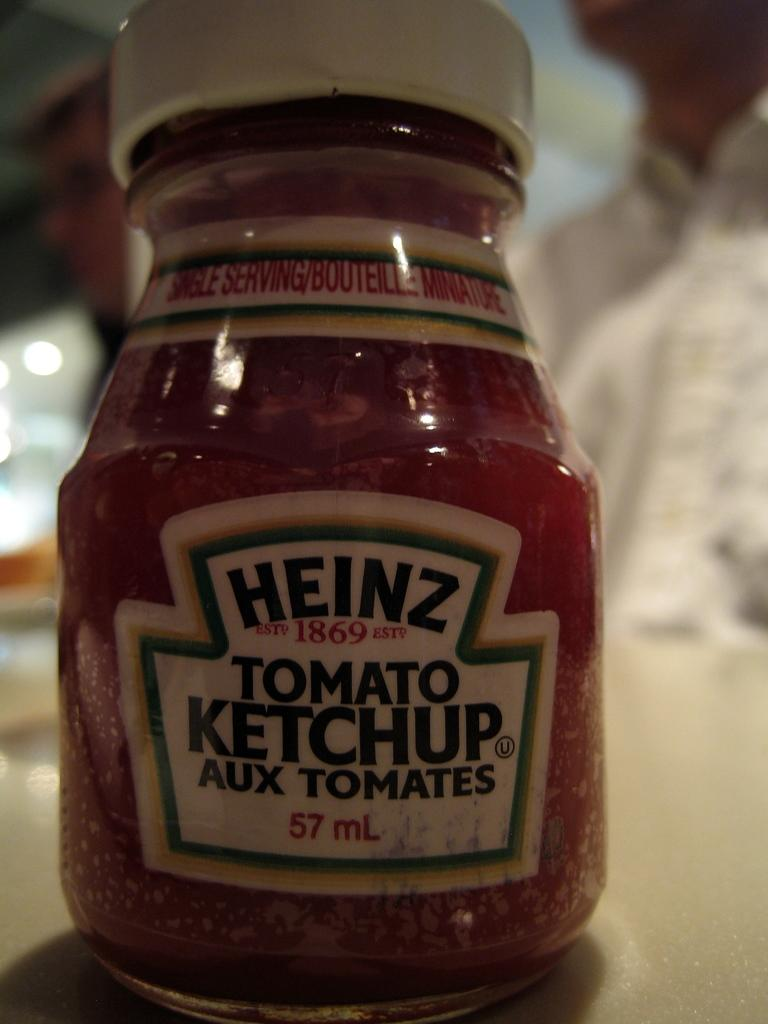What object is placed on the table in the image? There is a bottle placed on a table in the image. Can you describe anything else in the image besides the bottle? Yes, there is a person visible in the background of the image. What time does the clock on the table show in the image? There is no clock present in the image; only a bottle and a person in the background are visible. 